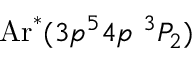Convert formula to latex. <formula><loc_0><loc_0><loc_500><loc_500>A r ^ { * } ( 3 p ^ { 5 } 4 p \ ^ { 3 } P _ { 2 } )</formula> 